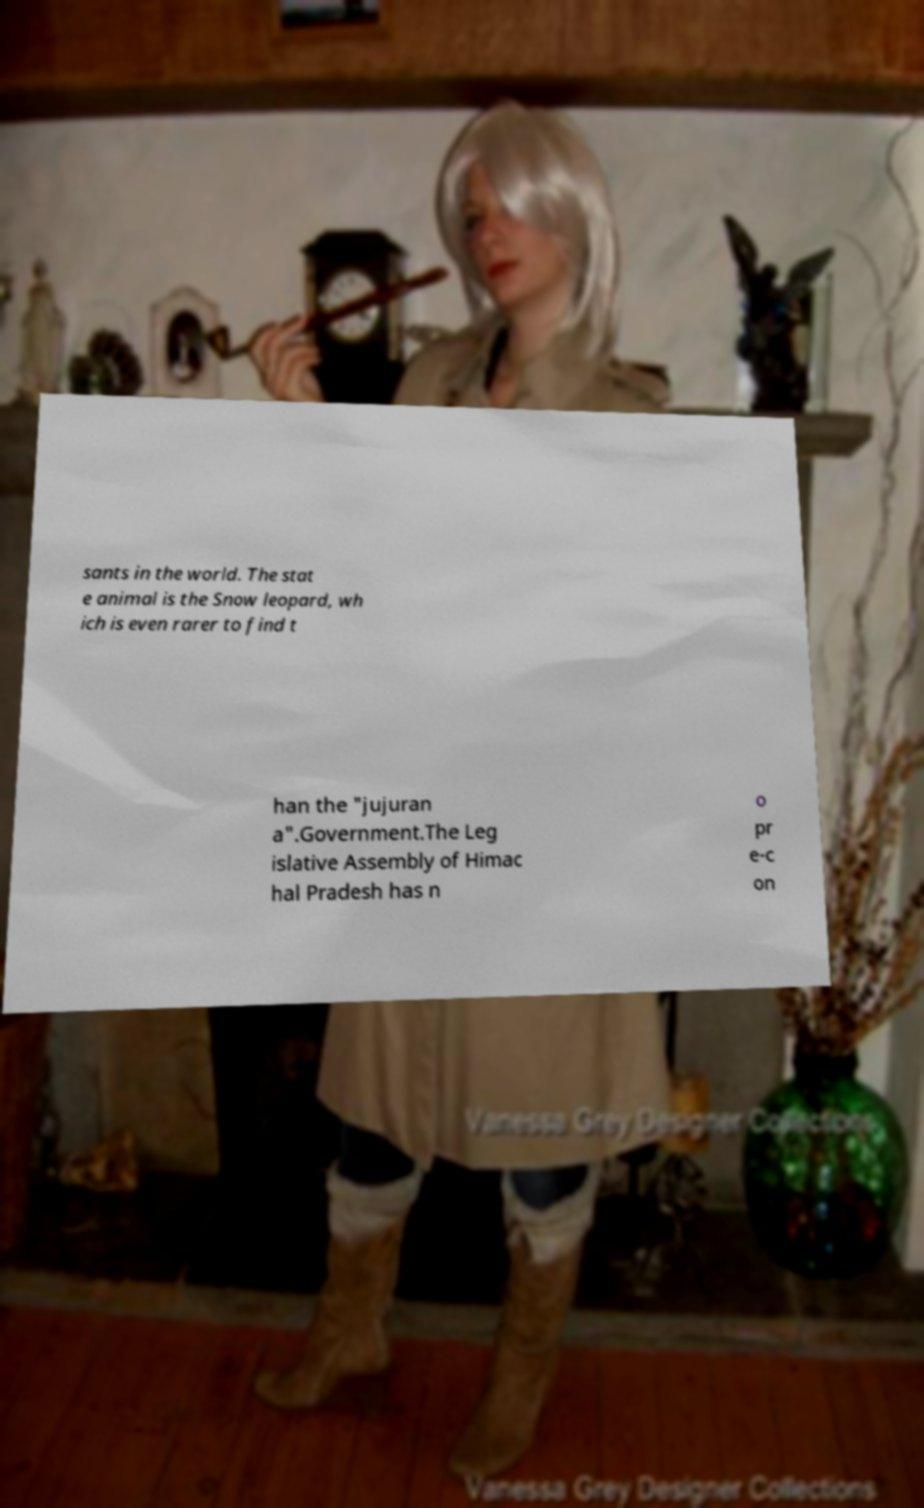Can you read and provide the text displayed in the image?This photo seems to have some interesting text. Can you extract and type it out for me? sants in the world. The stat e animal is the Snow leopard, wh ich is even rarer to find t han the "jujuran a".Government.The Leg islative Assembly of Himac hal Pradesh has n o pr e-c on 